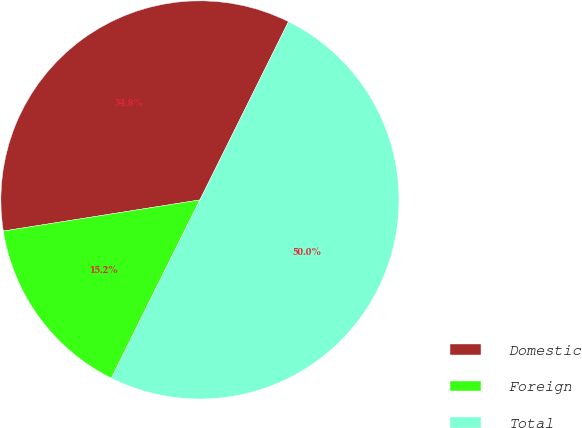<chart> <loc_0><loc_0><loc_500><loc_500><pie_chart><fcel>Domestic<fcel>Foreign<fcel>Total<nl><fcel>34.84%<fcel>15.16%<fcel>50.0%<nl></chart> 